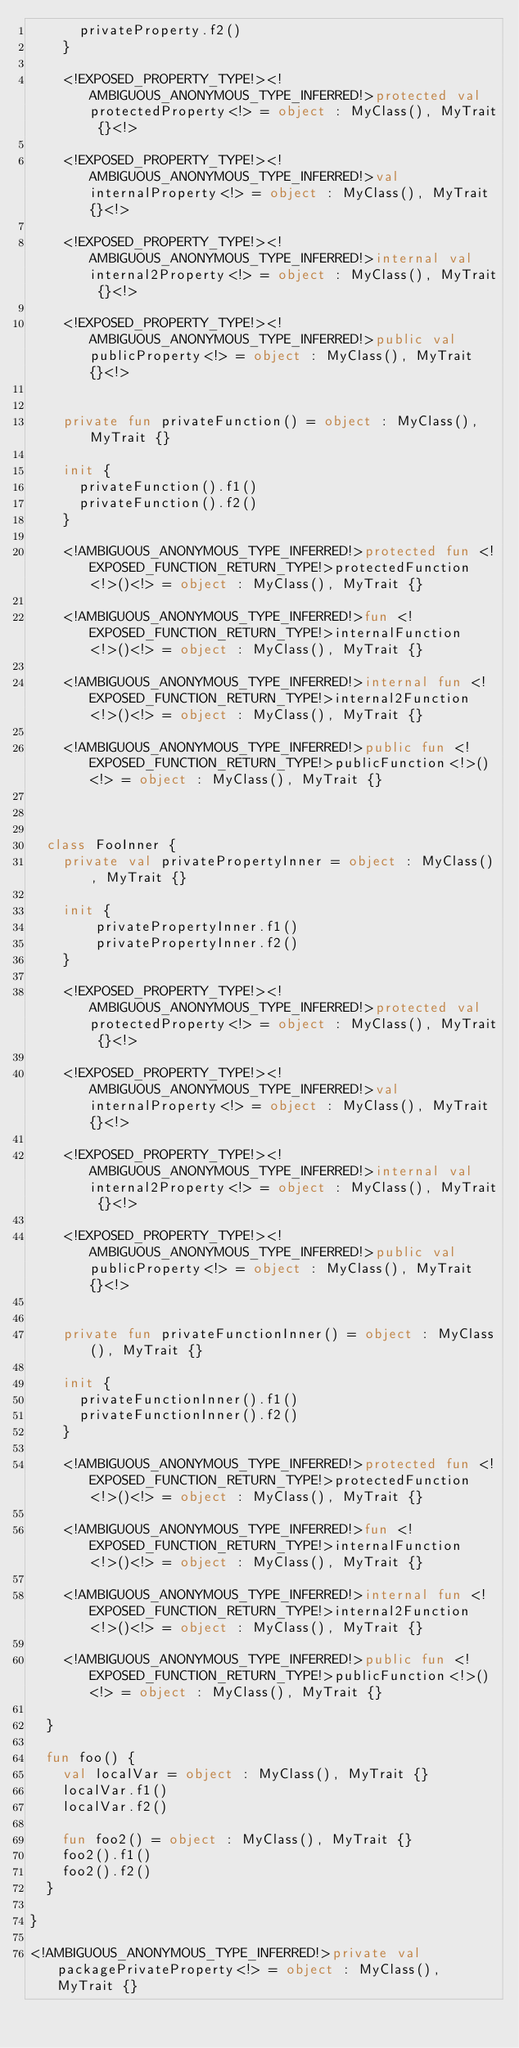<code> <loc_0><loc_0><loc_500><loc_500><_Kotlin_>      privateProperty.f2()
    }

    <!EXPOSED_PROPERTY_TYPE!><!AMBIGUOUS_ANONYMOUS_TYPE_INFERRED!>protected val protectedProperty<!> = object : MyClass(), MyTrait {}<!>

    <!EXPOSED_PROPERTY_TYPE!><!AMBIGUOUS_ANONYMOUS_TYPE_INFERRED!>val internalProperty<!> = object : MyClass(), MyTrait {}<!>

    <!EXPOSED_PROPERTY_TYPE!><!AMBIGUOUS_ANONYMOUS_TYPE_INFERRED!>internal val internal2Property<!> = object : MyClass(), MyTrait {}<!>

    <!EXPOSED_PROPERTY_TYPE!><!AMBIGUOUS_ANONYMOUS_TYPE_INFERRED!>public val publicProperty<!> = object : MyClass(), MyTrait {}<!>


    private fun privateFunction() = object : MyClass(), MyTrait {}

    init {
      privateFunction().f1()
      privateFunction().f2()
    }

    <!AMBIGUOUS_ANONYMOUS_TYPE_INFERRED!>protected fun <!EXPOSED_FUNCTION_RETURN_TYPE!>protectedFunction<!>()<!> = object : MyClass(), MyTrait {}

    <!AMBIGUOUS_ANONYMOUS_TYPE_INFERRED!>fun <!EXPOSED_FUNCTION_RETURN_TYPE!>internalFunction<!>()<!> = object : MyClass(), MyTrait {}

    <!AMBIGUOUS_ANONYMOUS_TYPE_INFERRED!>internal fun <!EXPOSED_FUNCTION_RETURN_TYPE!>internal2Function<!>()<!> = object : MyClass(), MyTrait {}

    <!AMBIGUOUS_ANONYMOUS_TYPE_INFERRED!>public fun <!EXPOSED_FUNCTION_RETURN_TYPE!>publicFunction<!>()<!> = object : MyClass(), MyTrait {}



  class FooInner {
    private val privatePropertyInner = object : MyClass(), MyTrait {}

    init {
        privatePropertyInner.f1()
        privatePropertyInner.f2()
    }

    <!EXPOSED_PROPERTY_TYPE!><!AMBIGUOUS_ANONYMOUS_TYPE_INFERRED!>protected val protectedProperty<!> = object : MyClass(), MyTrait {}<!>

    <!EXPOSED_PROPERTY_TYPE!><!AMBIGUOUS_ANONYMOUS_TYPE_INFERRED!>val internalProperty<!> = object : MyClass(), MyTrait {}<!>

    <!EXPOSED_PROPERTY_TYPE!><!AMBIGUOUS_ANONYMOUS_TYPE_INFERRED!>internal val internal2Property<!> = object : MyClass(), MyTrait {}<!>

    <!EXPOSED_PROPERTY_TYPE!><!AMBIGUOUS_ANONYMOUS_TYPE_INFERRED!>public val publicProperty<!> = object : MyClass(), MyTrait {}<!>


    private fun privateFunctionInner() = object : MyClass(), MyTrait {}

    init {
      privateFunctionInner().f1()
      privateFunctionInner().f2()
    }

    <!AMBIGUOUS_ANONYMOUS_TYPE_INFERRED!>protected fun <!EXPOSED_FUNCTION_RETURN_TYPE!>protectedFunction<!>()<!> = object : MyClass(), MyTrait {}

    <!AMBIGUOUS_ANONYMOUS_TYPE_INFERRED!>fun <!EXPOSED_FUNCTION_RETURN_TYPE!>internalFunction<!>()<!> = object : MyClass(), MyTrait {}

    <!AMBIGUOUS_ANONYMOUS_TYPE_INFERRED!>internal fun <!EXPOSED_FUNCTION_RETURN_TYPE!>internal2Function<!>()<!> = object : MyClass(), MyTrait {}

    <!AMBIGUOUS_ANONYMOUS_TYPE_INFERRED!>public fun <!EXPOSED_FUNCTION_RETURN_TYPE!>publicFunction<!>()<!> = object : MyClass(), MyTrait {}

  }

  fun foo() {
    val localVar = object : MyClass(), MyTrait {}
    localVar.f1()
    localVar.f2()

    fun foo2() = object : MyClass(), MyTrait {}
    foo2().f1()
    foo2().f2()
  }

}

<!AMBIGUOUS_ANONYMOUS_TYPE_INFERRED!>private val packagePrivateProperty<!> = object : MyClass(), MyTrait {}
</code> 